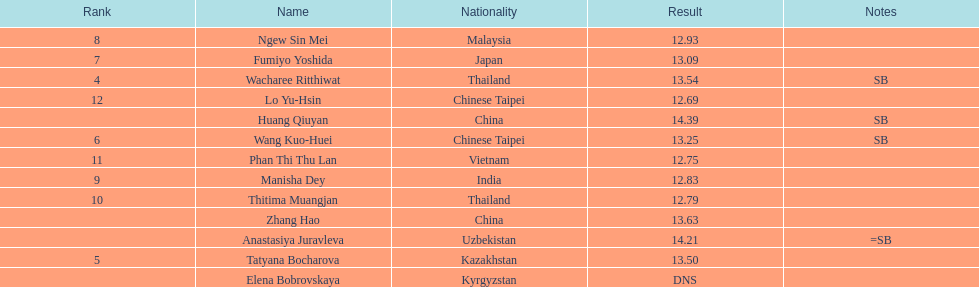How long was manisha dey's jump? 12.83. 